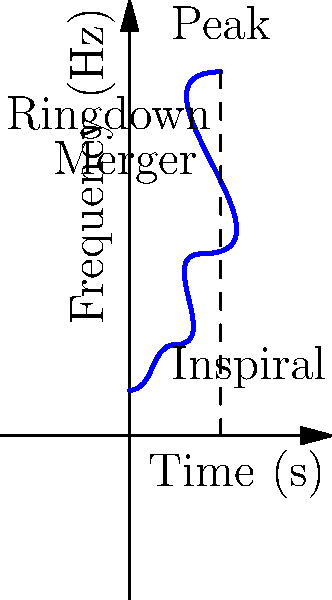In the time-frequency spectrogram of a gravitational wave signal from a binary black hole merger shown above, what physical process corresponds to the rapid increase in frequency near the end of the signal? To answer this question, let's analyze the time-frequency spectrogram step by step:

1. The spectrogram shows the evolution of frequency over time for a gravitational wave signal from a binary black hole merger.

2. We can identify three main phases in the signal:
   a) Inspiral: The initial part where frequency slowly increases
   b) Merger: The middle part where frequency rapidly increases
   c) Ringdown: The final part where frequency stabilizes

3. The question asks about the rapid increase in frequency near the end of the signal.

4. This rapid frequency increase corresponds to the merger phase of the binary black hole system.

5. During the merger:
   - The black holes are orbiting each other at extremely high speeds
   - They are very close to each other, experiencing strong gravitational fields
   - The orbital frequency increases dramatically as they spiral inward

6. This rapid orbital motion causes the emission of gravitational waves with rapidly increasing frequency.

7. The peak of the frequency curve marks the moment of merger, after which the ringdown phase begins.

Therefore, the rapid increase in frequency near the end of the signal corresponds to the merger process of the binary black hole system.
Answer: Merger 